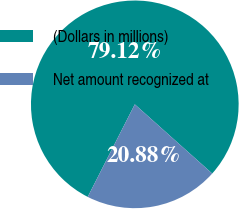<chart> <loc_0><loc_0><loc_500><loc_500><pie_chart><fcel>(Dollars in millions)<fcel>Net amount recognized at<nl><fcel>79.12%<fcel>20.88%<nl></chart> 